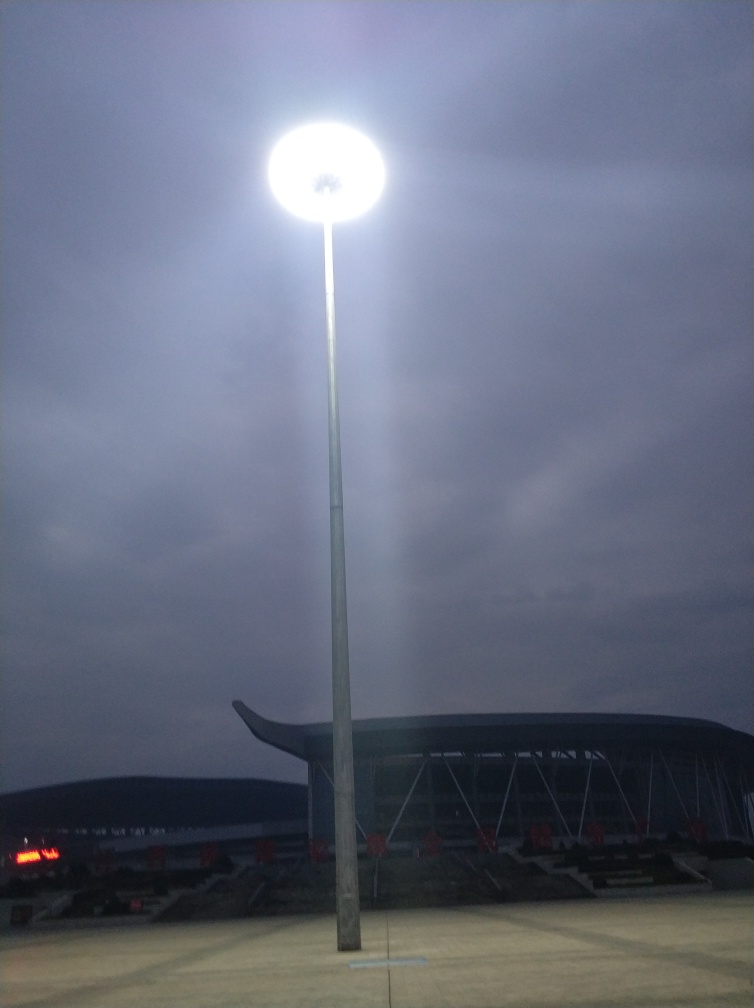What can be said about the texture details of the buildings? While the intense illumination from the floodlight might somewhat obscure finer details, the visible elements of the building exhibit discernible texture. The areas not directly under the light, such as the roof structure and the seating area of the stadium, demonstrate texture details that are visible yet not enhanced due to the low lighting conditions, suggesting that the correct option would be C. Visible. 